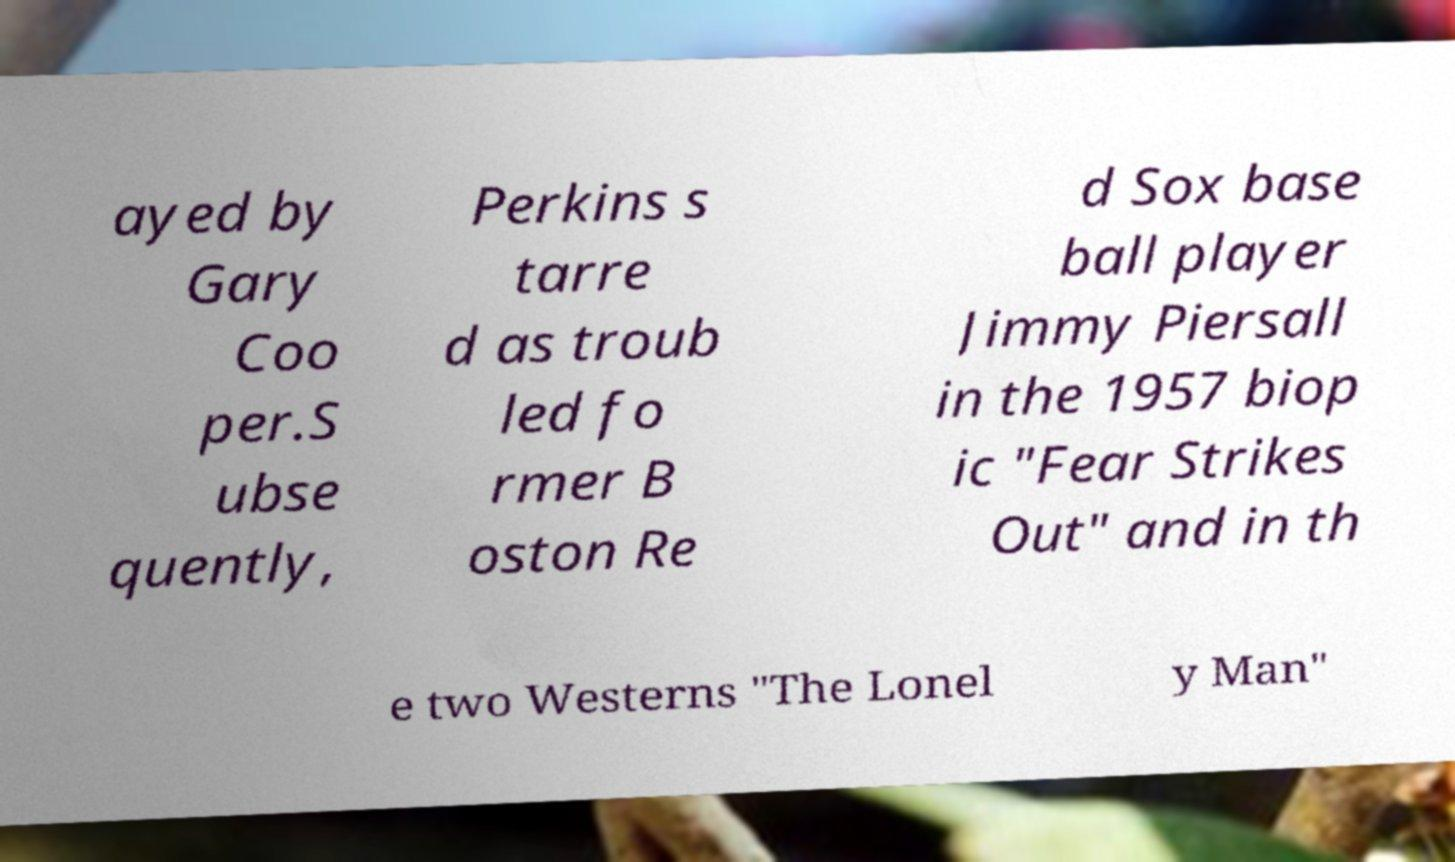What messages or text are displayed in this image? I need them in a readable, typed format. ayed by Gary Coo per.S ubse quently, Perkins s tarre d as troub led fo rmer B oston Re d Sox base ball player Jimmy Piersall in the 1957 biop ic "Fear Strikes Out" and in th e two Westerns "The Lonel y Man" 